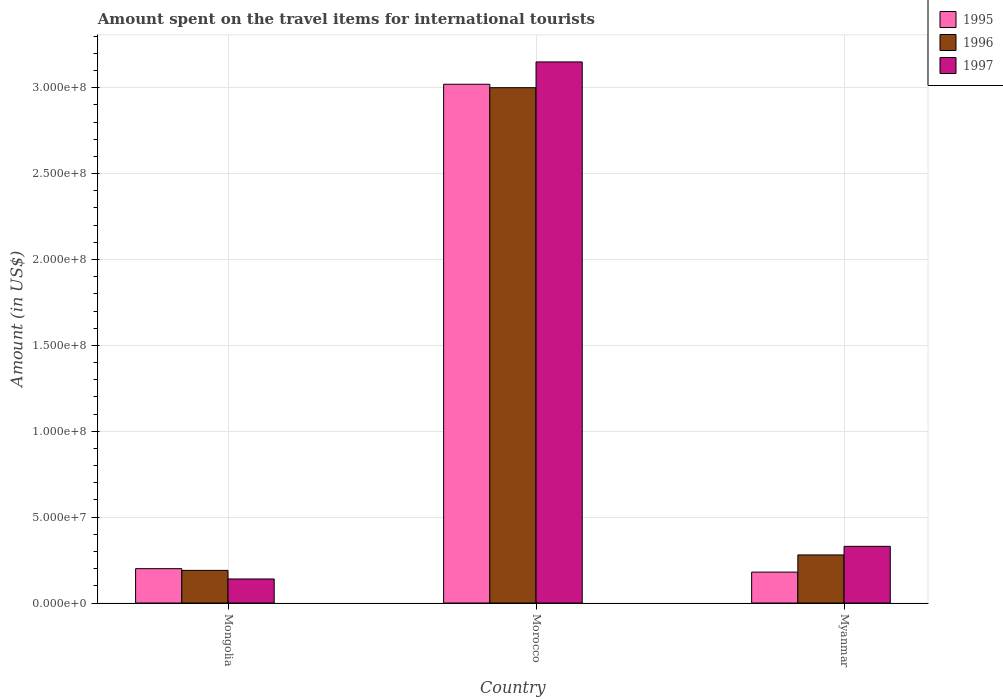Are the number of bars per tick equal to the number of legend labels?
Provide a succinct answer. Yes. Are the number of bars on each tick of the X-axis equal?
Your answer should be very brief. Yes. What is the label of the 1st group of bars from the left?
Make the answer very short. Mongolia. In how many cases, is the number of bars for a given country not equal to the number of legend labels?
Your response must be concise. 0. What is the amount spent on the travel items for international tourists in 1997 in Mongolia?
Offer a very short reply. 1.40e+07. Across all countries, what is the maximum amount spent on the travel items for international tourists in 1996?
Offer a terse response. 3.00e+08. Across all countries, what is the minimum amount spent on the travel items for international tourists in 1996?
Give a very brief answer. 1.90e+07. In which country was the amount spent on the travel items for international tourists in 1995 maximum?
Offer a terse response. Morocco. In which country was the amount spent on the travel items for international tourists in 1997 minimum?
Give a very brief answer. Mongolia. What is the total amount spent on the travel items for international tourists in 1997 in the graph?
Keep it short and to the point. 3.62e+08. What is the difference between the amount spent on the travel items for international tourists in 1997 in Mongolia and that in Morocco?
Offer a terse response. -3.01e+08. What is the difference between the amount spent on the travel items for international tourists in 1997 in Myanmar and the amount spent on the travel items for international tourists in 1996 in Morocco?
Ensure brevity in your answer.  -2.67e+08. What is the average amount spent on the travel items for international tourists in 1997 per country?
Your answer should be very brief. 1.21e+08. What is the difference between the amount spent on the travel items for international tourists of/in 1995 and amount spent on the travel items for international tourists of/in 1996 in Mongolia?
Offer a very short reply. 1.00e+06. In how many countries, is the amount spent on the travel items for international tourists in 1996 greater than 280000000 US$?
Your answer should be compact. 1. What is the ratio of the amount spent on the travel items for international tourists in 1995 in Mongolia to that in Myanmar?
Your response must be concise. 1.11. Is the amount spent on the travel items for international tourists in 1996 in Mongolia less than that in Morocco?
Keep it short and to the point. Yes. Is the difference between the amount spent on the travel items for international tourists in 1995 in Mongolia and Morocco greater than the difference between the amount spent on the travel items for international tourists in 1996 in Mongolia and Morocco?
Offer a terse response. No. What is the difference between the highest and the second highest amount spent on the travel items for international tourists in 1997?
Make the answer very short. 2.82e+08. What is the difference between the highest and the lowest amount spent on the travel items for international tourists in 1995?
Give a very brief answer. 2.84e+08. What does the 2nd bar from the left in Morocco represents?
Your answer should be very brief. 1996. What does the 1st bar from the right in Mongolia represents?
Offer a very short reply. 1997. How many bars are there?
Your answer should be very brief. 9. What is the difference between two consecutive major ticks on the Y-axis?
Your answer should be very brief. 5.00e+07. Are the values on the major ticks of Y-axis written in scientific E-notation?
Offer a terse response. Yes. Does the graph contain grids?
Ensure brevity in your answer.  Yes. How are the legend labels stacked?
Offer a terse response. Vertical. What is the title of the graph?
Make the answer very short. Amount spent on the travel items for international tourists. What is the label or title of the X-axis?
Your answer should be very brief. Country. What is the label or title of the Y-axis?
Provide a short and direct response. Amount (in US$). What is the Amount (in US$) in 1995 in Mongolia?
Ensure brevity in your answer.  2.00e+07. What is the Amount (in US$) in 1996 in Mongolia?
Provide a succinct answer. 1.90e+07. What is the Amount (in US$) of 1997 in Mongolia?
Your answer should be compact. 1.40e+07. What is the Amount (in US$) in 1995 in Morocco?
Offer a very short reply. 3.02e+08. What is the Amount (in US$) of 1996 in Morocco?
Offer a terse response. 3.00e+08. What is the Amount (in US$) in 1997 in Morocco?
Provide a succinct answer. 3.15e+08. What is the Amount (in US$) of 1995 in Myanmar?
Offer a terse response. 1.80e+07. What is the Amount (in US$) in 1996 in Myanmar?
Ensure brevity in your answer.  2.80e+07. What is the Amount (in US$) in 1997 in Myanmar?
Your answer should be compact. 3.30e+07. Across all countries, what is the maximum Amount (in US$) of 1995?
Keep it short and to the point. 3.02e+08. Across all countries, what is the maximum Amount (in US$) of 1996?
Your response must be concise. 3.00e+08. Across all countries, what is the maximum Amount (in US$) in 1997?
Offer a terse response. 3.15e+08. Across all countries, what is the minimum Amount (in US$) in 1995?
Ensure brevity in your answer.  1.80e+07. Across all countries, what is the minimum Amount (in US$) of 1996?
Offer a terse response. 1.90e+07. Across all countries, what is the minimum Amount (in US$) of 1997?
Your answer should be very brief. 1.40e+07. What is the total Amount (in US$) in 1995 in the graph?
Give a very brief answer. 3.40e+08. What is the total Amount (in US$) of 1996 in the graph?
Offer a terse response. 3.47e+08. What is the total Amount (in US$) of 1997 in the graph?
Offer a very short reply. 3.62e+08. What is the difference between the Amount (in US$) of 1995 in Mongolia and that in Morocco?
Your response must be concise. -2.82e+08. What is the difference between the Amount (in US$) in 1996 in Mongolia and that in Morocco?
Keep it short and to the point. -2.81e+08. What is the difference between the Amount (in US$) in 1997 in Mongolia and that in Morocco?
Your answer should be very brief. -3.01e+08. What is the difference between the Amount (in US$) of 1995 in Mongolia and that in Myanmar?
Keep it short and to the point. 2.00e+06. What is the difference between the Amount (in US$) in 1996 in Mongolia and that in Myanmar?
Offer a very short reply. -9.00e+06. What is the difference between the Amount (in US$) of 1997 in Mongolia and that in Myanmar?
Your answer should be very brief. -1.90e+07. What is the difference between the Amount (in US$) in 1995 in Morocco and that in Myanmar?
Keep it short and to the point. 2.84e+08. What is the difference between the Amount (in US$) of 1996 in Morocco and that in Myanmar?
Provide a succinct answer. 2.72e+08. What is the difference between the Amount (in US$) in 1997 in Morocco and that in Myanmar?
Offer a terse response. 2.82e+08. What is the difference between the Amount (in US$) of 1995 in Mongolia and the Amount (in US$) of 1996 in Morocco?
Give a very brief answer. -2.80e+08. What is the difference between the Amount (in US$) of 1995 in Mongolia and the Amount (in US$) of 1997 in Morocco?
Keep it short and to the point. -2.95e+08. What is the difference between the Amount (in US$) in 1996 in Mongolia and the Amount (in US$) in 1997 in Morocco?
Offer a very short reply. -2.96e+08. What is the difference between the Amount (in US$) of 1995 in Mongolia and the Amount (in US$) of 1996 in Myanmar?
Ensure brevity in your answer.  -8.00e+06. What is the difference between the Amount (in US$) of 1995 in Mongolia and the Amount (in US$) of 1997 in Myanmar?
Provide a short and direct response. -1.30e+07. What is the difference between the Amount (in US$) of 1996 in Mongolia and the Amount (in US$) of 1997 in Myanmar?
Offer a terse response. -1.40e+07. What is the difference between the Amount (in US$) in 1995 in Morocco and the Amount (in US$) in 1996 in Myanmar?
Your answer should be very brief. 2.74e+08. What is the difference between the Amount (in US$) of 1995 in Morocco and the Amount (in US$) of 1997 in Myanmar?
Keep it short and to the point. 2.69e+08. What is the difference between the Amount (in US$) in 1996 in Morocco and the Amount (in US$) in 1997 in Myanmar?
Keep it short and to the point. 2.67e+08. What is the average Amount (in US$) in 1995 per country?
Offer a very short reply. 1.13e+08. What is the average Amount (in US$) in 1996 per country?
Offer a very short reply. 1.16e+08. What is the average Amount (in US$) in 1997 per country?
Make the answer very short. 1.21e+08. What is the difference between the Amount (in US$) of 1995 and Amount (in US$) of 1997 in Mongolia?
Offer a very short reply. 6.00e+06. What is the difference between the Amount (in US$) in 1996 and Amount (in US$) in 1997 in Mongolia?
Your answer should be very brief. 5.00e+06. What is the difference between the Amount (in US$) of 1995 and Amount (in US$) of 1996 in Morocco?
Provide a short and direct response. 2.00e+06. What is the difference between the Amount (in US$) in 1995 and Amount (in US$) in 1997 in Morocco?
Give a very brief answer. -1.30e+07. What is the difference between the Amount (in US$) of 1996 and Amount (in US$) of 1997 in Morocco?
Offer a terse response. -1.50e+07. What is the difference between the Amount (in US$) of 1995 and Amount (in US$) of 1996 in Myanmar?
Your response must be concise. -1.00e+07. What is the difference between the Amount (in US$) of 1995 and Amount (in US$) of 1997 in Myanmar?
Offer a terse response. -1.50e+07. What is the difference between the Amount (in US$) in 1996 and Amount (in US$) in 1997 in Myanmar?
Provide a succinct answer. -5.00e+06. What is the ratio of the Amount (in US$) of 1995 in Mongolia to that in Morocco?
Offer a very short reply. 0.07. What is the ratio of the Amount (in US$) in 1996 in Mongolia to that in Morocco?
Your response must be concise. 0.06. What is the ratio of the Amount (in US$) in 1997 in Mongolia to that in Morocco?
Make the answer very short. 0.04. What is the ratio of the Amount (in US$) of 1995 in Mongolia to that in Myanmar?
Keep it short and to the point. 1.11. What is the ratio of the Amount (in US$) of 1996 in Mongolia to that in Myanmar?
Keep it short and to the point. 0.68. What is the ratio of the Amount (in US$) in 1997 in Mongolia to that in Myanmar?
Offer a very short reply. 0.42. What is the ratio of the Amount (in US$) in 1995 in Morocco to that in Myanmar?
Keep it short and to the point. 16.78. What is the ratio of the Amount (in US$) of 1996 in Morocco to that in Myanmar?
Keep it short and to the point. 10.71. What is the ratio of the Amount (in US$) of 1997 in Morocco to that in Myanmar?
Provide a short and direct response. 9.55. What is the difference between the highest and the second highest Amount (in US$) in 1995?
Your response must be concise. 2.82e+08. What is the difference between the highest and the second highest Amount (in US$) in 1996?
Your answer should be very brief. 2.72e+08. What is the difference between the highest and the second highest Amount (in US$) in 1997?
Make the answer very short. 2.82e+08. What is the difference between the highest and the lowest Amount (in US$) of 1995?
Provide a succinct answer. 2.84e+08. What is the difference between the highest and the lowest Amount (in US$) of 1996?
Your answer should be compact. 2.81e+08. What is the difference between the highest and the lowest Amount (in US$) in 1997?
Ensure brevity in your answer.  3.01e+08. 